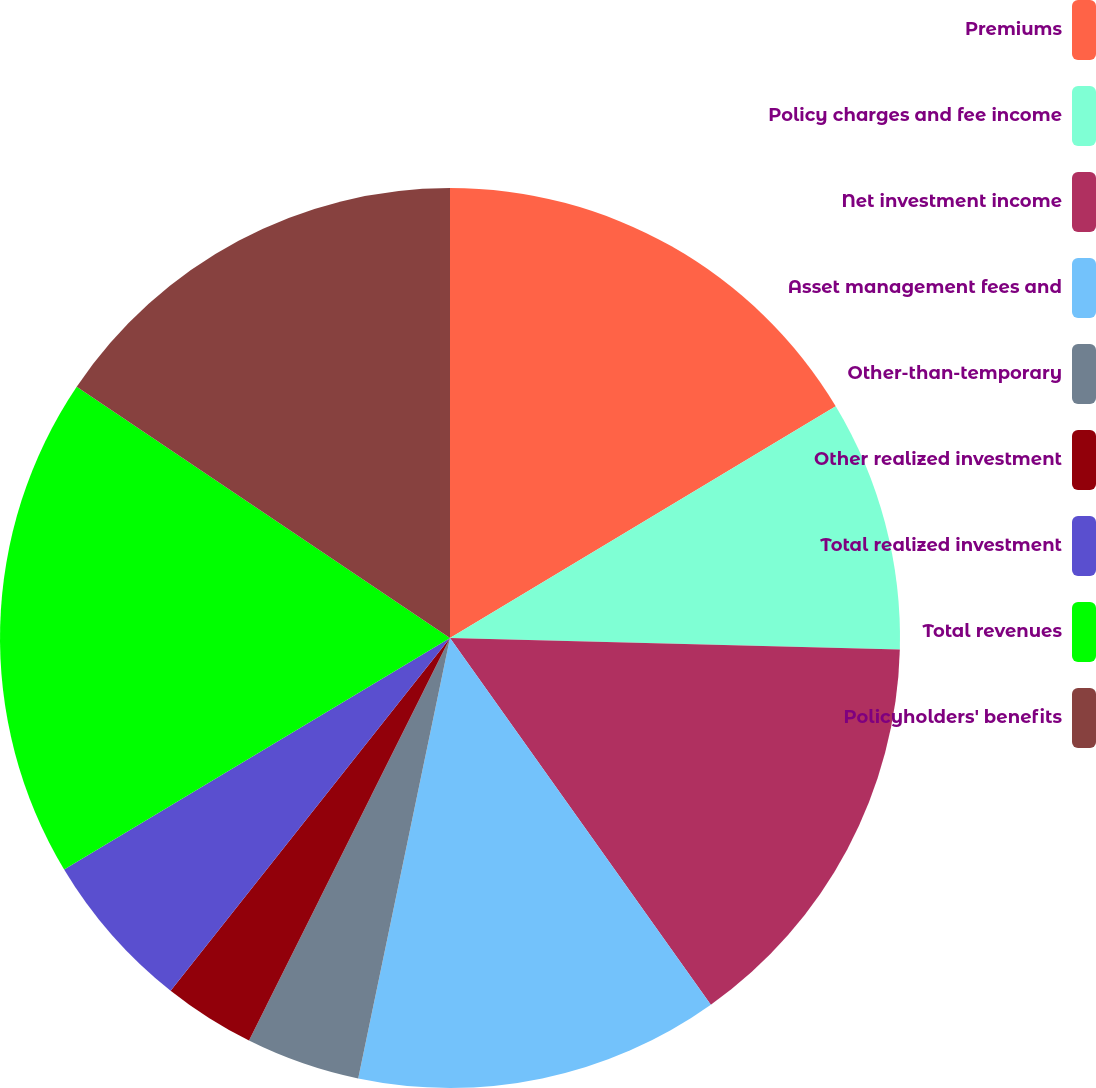Convert chart. <chart><loc_0><loc_0><loc_500><loc_500><pie_chart><fcel>Premiums<fcel>Policy charges and fee income<fcel>Net investment income<fcel>Asset management fees and<fcel>Other-than-temporary<fcel>Other realized investment<fcel>Total realized investment<fcel>Total revenues<fcel>Policyholders' benefits<nl><fcel>16.39%<fcel>9.02%<fcel>14.75%<fcel>13.11%<fcel>4.1%<fcel>3.29%<fcel>5.74%<fcel>18.03%<fcel>15.57%<nl></chart> 